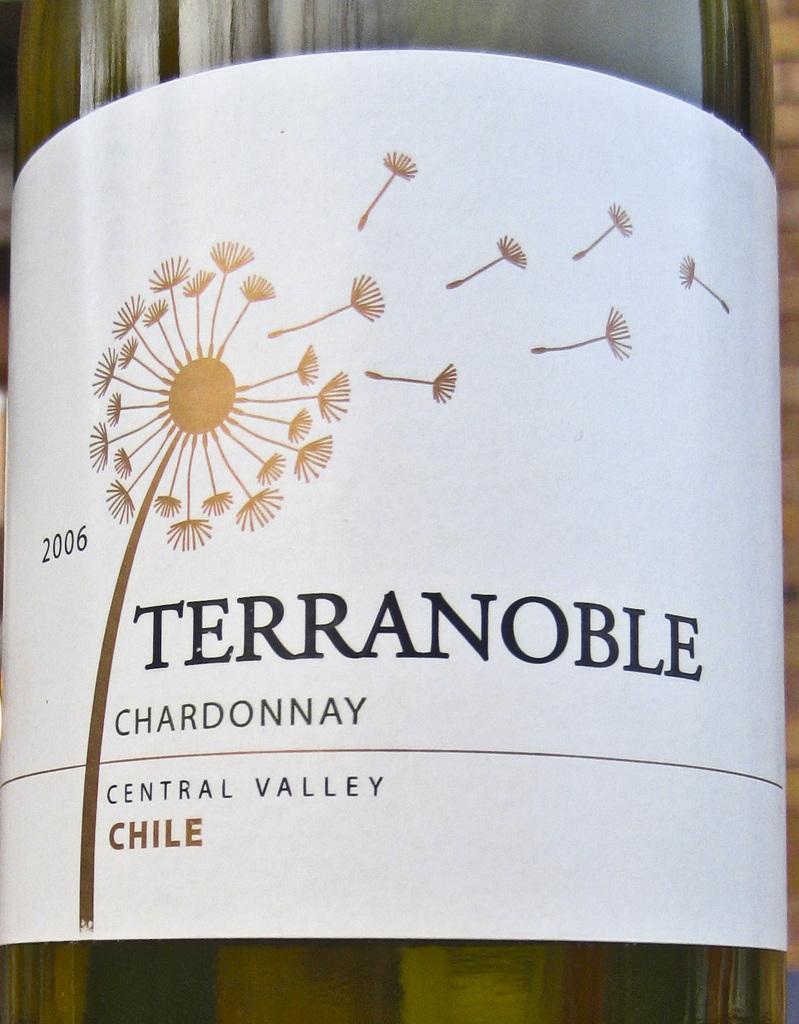What type of wine is pictured?
Your answer should be compact. Chardonnay. What country did the wine come from?
Provide a succinct answer. Chile. 